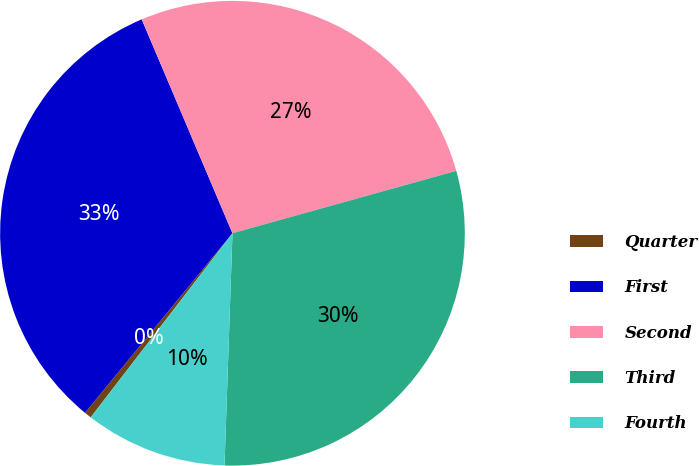Convert chart to OTSL. <chart><loc_0><loc_0><loc_500><loc_500><pie_chart><fcel>Quarter<fcel>First<fcel>Second<fcel>Third<fcel>Fourth<nl><fcel>0.5%<fcel>32.67%<fcel>27.06%<fcel>29.87%<fcel>9.9%<nl></chart> 